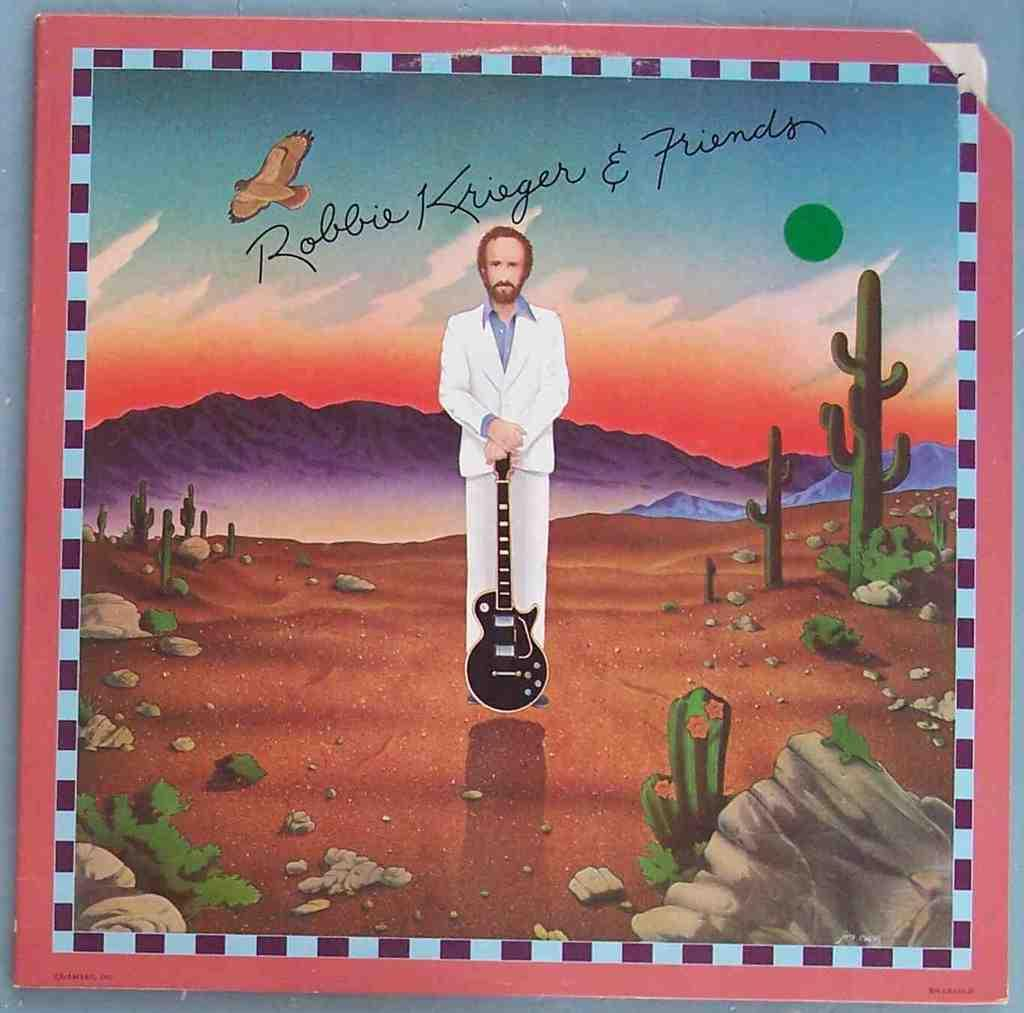<image>
Write a terse but informative summary of the picture. An illustration of a man holding a guitar signed "Robbie Krieger and friends". 